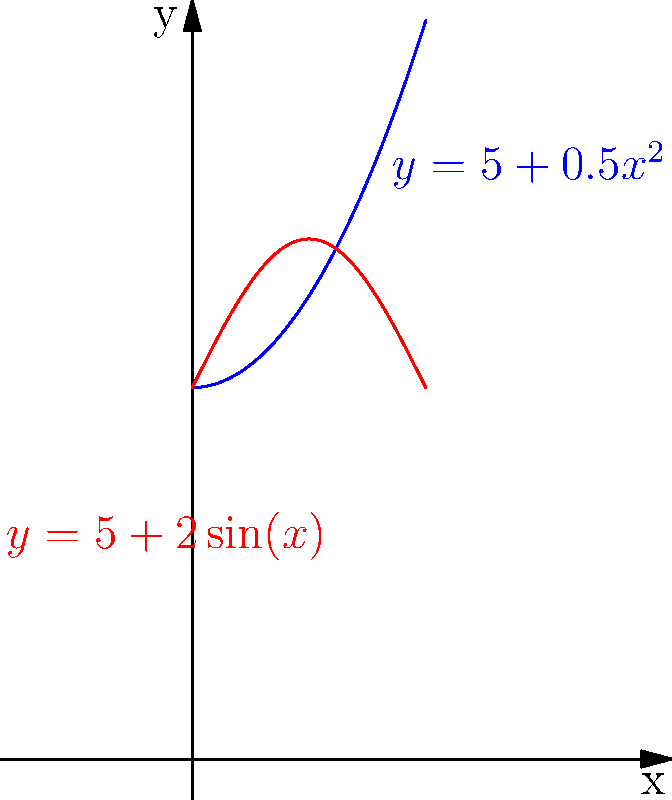A traditional Bolivian ceramic vase has a shape that can be modeled by rotating the region bounded by the curves $y=5+0.5x^2$, $y=5+2\sin(x)$, and the y-axis about the y-axis. Calculate the volume of this vase using the method of cylindrical shells. Use $\pi \approx 3.14$ and round your answer to the nearest cubic centimeter. To solve this problem, we'll use the method of cylindrical shells:

1) The volume formula using cylindrical shells is:
   $$V = 2\pi \int_a^b x[f(x)-g(x)]dx$$
   where $f(x)$ is the outer function and $g(x)$ is the inner function.

2) In this case:
   $f(x) = 5+0.5x^2$
   $g(x) = 5+2\sin(x)$
   $a = 0$ and $b = \pi$

3) Substituting into the formula:
   $$V = 2\pi \int_0^\pi x[(5+0.5x^2)-(5+2\sin(x))]dx$$

4) Simplify:
   $$V = 2\pi \int_0^\pi x(0.5x^2-2\sin(x))dx$$

5) Distribute $x$:
   $$V = 2\pi \int_0^\pi (0.5x^3-2x\sin(x))dx$$

6) Integrate:
   $$V = 2\pi [\frac{1}{8}x^4+2(x\cos(x)+\sin(x))]_0^\pi$$

7) Evaluate the integral:
   $$V = 2\pi [\frac{1}{8}\pi^4+2(\pi\cos(\pi)+\sin(\pi))-0]$$
   $$V = 2\pi [\frac{1}{8}\pi^4-2\pi]$$

8) Calculate:
   $$V \approx 2(3.14)[\frac{1}{8}(3.14)^4-2(3.14)]$$
   $$V \approx 6.28[24.29-6.28]$$
   $$V \approx 6.28(18.01)$$
   $$V \approx 113.10$$

9) Rounding to the nearest cubic centimeter:
   $$V \approx 113 \text{ cm}^3$$
Answer: 113 cm³ 